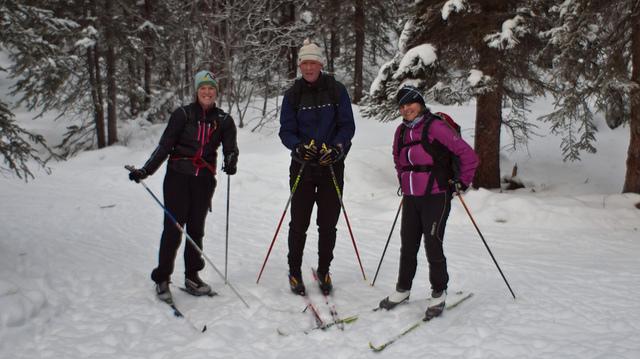Why do the people have hats on their heads?
Be succinct. Keep warm. Is he wearing glasses?
Write a very short answer. No. Where does it say Columbia?
Short answer required. Jacket. How many people are there?
Write a very short answer. 3. What are the people doing?
Keep it brief. Skiing. How many people are shown?
Keep it brief. 3. Are all of the skiers wearing red vests?
Write a very short answer. No. Are the people bundled up?
Quick response, please. Yes. What color coat is the tallest person pictured wearing?
Quick response, please. Black. 